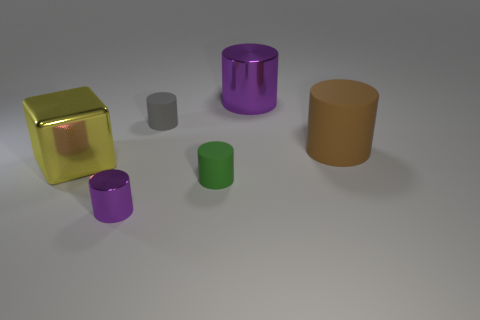Subtract all tiny purple metal cylinders. How many cylinders are left? 4 Subtract 2 cylinders. How many cylinders are left? 3 Subtract all brown cylinders. How many cylinders are left? 4 Subtract all red cylinders. Subtract all blue spheres. How many cylinders are left? 5 Add 3 brown rubber cylinders. How many objects exist? 9 Subtract all cylinders. How many objects are left? 1 Add 1 gray rubber things. How many gray rubber things are left? 2 Add 4 green cylinders. How many green cylinders exist? 5 Subtract 0 purple blocks. How many objects are left? 6 Subtract all small brown rubber blocks. Subtract all gray rubber things. How many objects are left? 5 